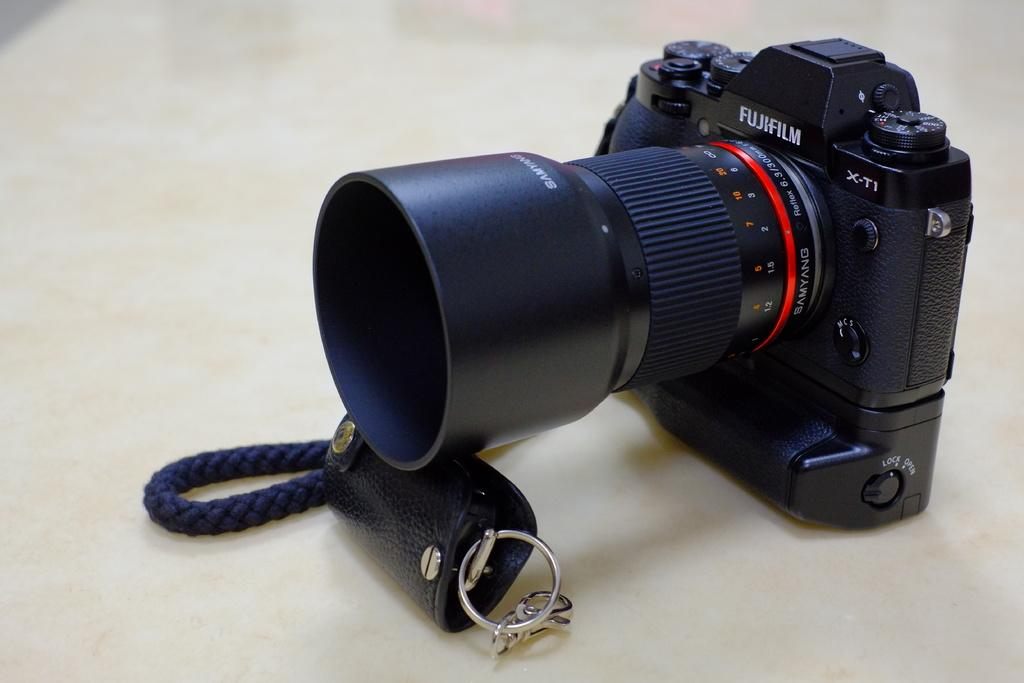<image>
Write a terse but informative summary of the picture. Black Fujifilm camera on top of a keychain. 